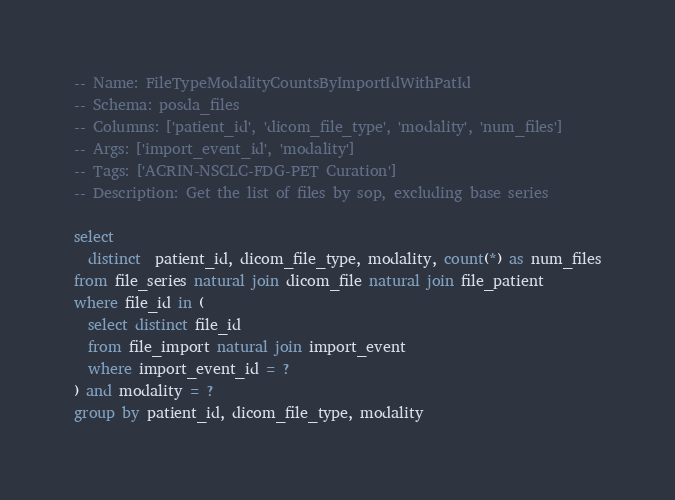Convert code to text. <code><loc_0><loc_0><loc_500><loc_500><_SQL_>-- Name: FileTypeModalityCountsByImportIdWithPatId
-- Schema: posda_files
-- Columns: ['patient_id', 'dicom_file_type', 'modality', 'num_files']
-- Args: ['import_event_id', 'modality']
-- Tags: ['ACRIN-NSCLC-FDG-PET Curation']
-- Description: Get the list of files by sop, excluding base series

select
  distinct  patient_id, dicom_file_type, modality, count(*) as num_files
from file_series natural join dicom_file natural join file_patient
where file_id in (
  select distinct file_id
  from file_import natural join import_event
  where import_event_id = ?
) and modality = ?
group by patient_id, dicom_file_type, modality</code> 